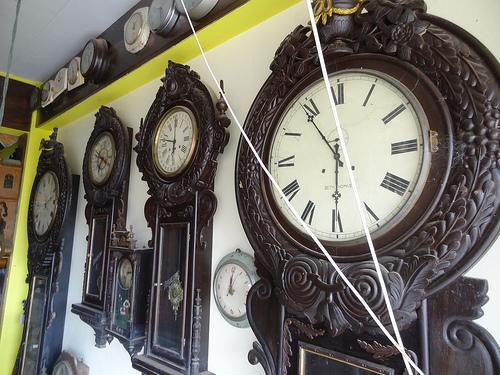Mention the primary focus of the image and its characteristics. An array of clocks with varying times and designs are displayed on a white wall, including round faces, Roman numerals, and decorative elements. Quickly describe the primary object or scene in the photograph and its main attributes. Multiple wall clocks with unique styles and sizes, like round faces and carved details, are mounted on a white wall, each displaying various times. Give a brief description of the scene in the picture. The image features a collection of wall clocks hanging on a white wall, each with different designs, sizes, and displaying different times. Identify the key subject of the image and briefly discuss its characteristics. A white wall adorned with an assortment of clocks, each varying in style, size, and displayed time, including those with round faces, decorative elements, and mixed colors. In a concise manner, describe the main elements visible in the image. There are several clocks on a white wall with diverse styles and sizes, such as round faces and wooden carvings, showing different times. Explain what the image mainly consists of and highlight the noticeable details. The image contains a multitude of wall clocks on a white wall, showcasing different designs such as round faces, intricate carvings, and a mix of displayed times. What is the most striking element of the image and its features? A large number of wall clocks with distinct designs, such as round faces and ornate details, are displayed on a white wall, each showing different times. In the image, what is the main focus and its distinguishing features? Various wall clocks with diverse designs, from round faces and ornate details to different sizes, all hanging on a white wall and displaying unique times. Provide a short summary of the most noticeable aspects of the image. The image shows a variety of wall clocks on a white wall, each with unique designs like round faces, decorative carvings, and displaying assorted times. What do you mainly observe in the picture with their distinct features? Numerous wall clocks, varying in style and size, can be seen mounted on a white wall, with some featuring round faces, ornate carvings, and differing times. 